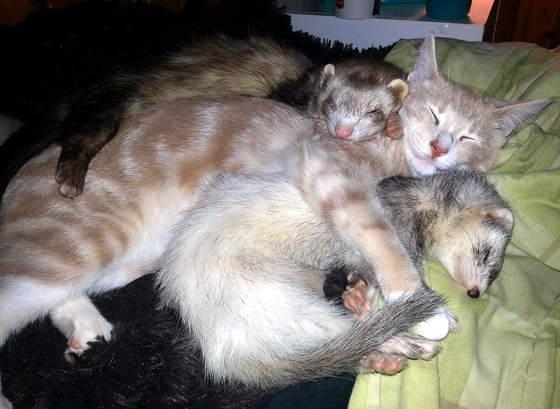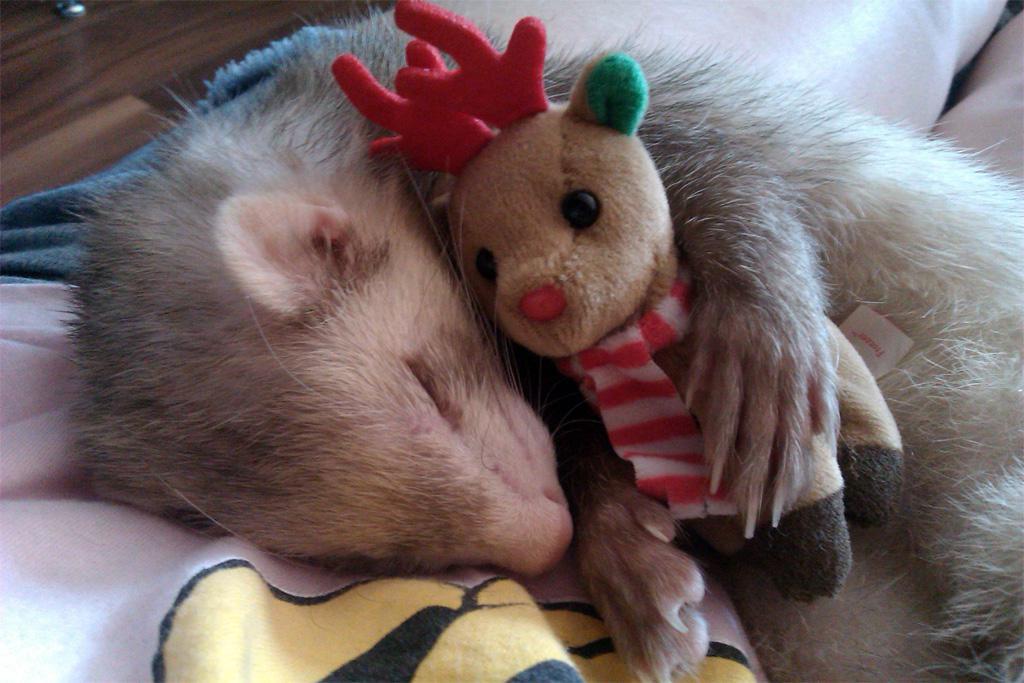The first image is the image on the left, the second image is the image on the right. Analyze the images presented: Is the assertion "One image shows two ferrets sleeping with a cat in between them, and the other shows exactly two animal faces side-by-side." valid? Answer yes or no. Yes. The first image is the image on the left, the second image is the image on the right. Examine the images to the left and right. Is the description "There is more than one animal species in the image." accurate? Answer yes or no. Yes. 